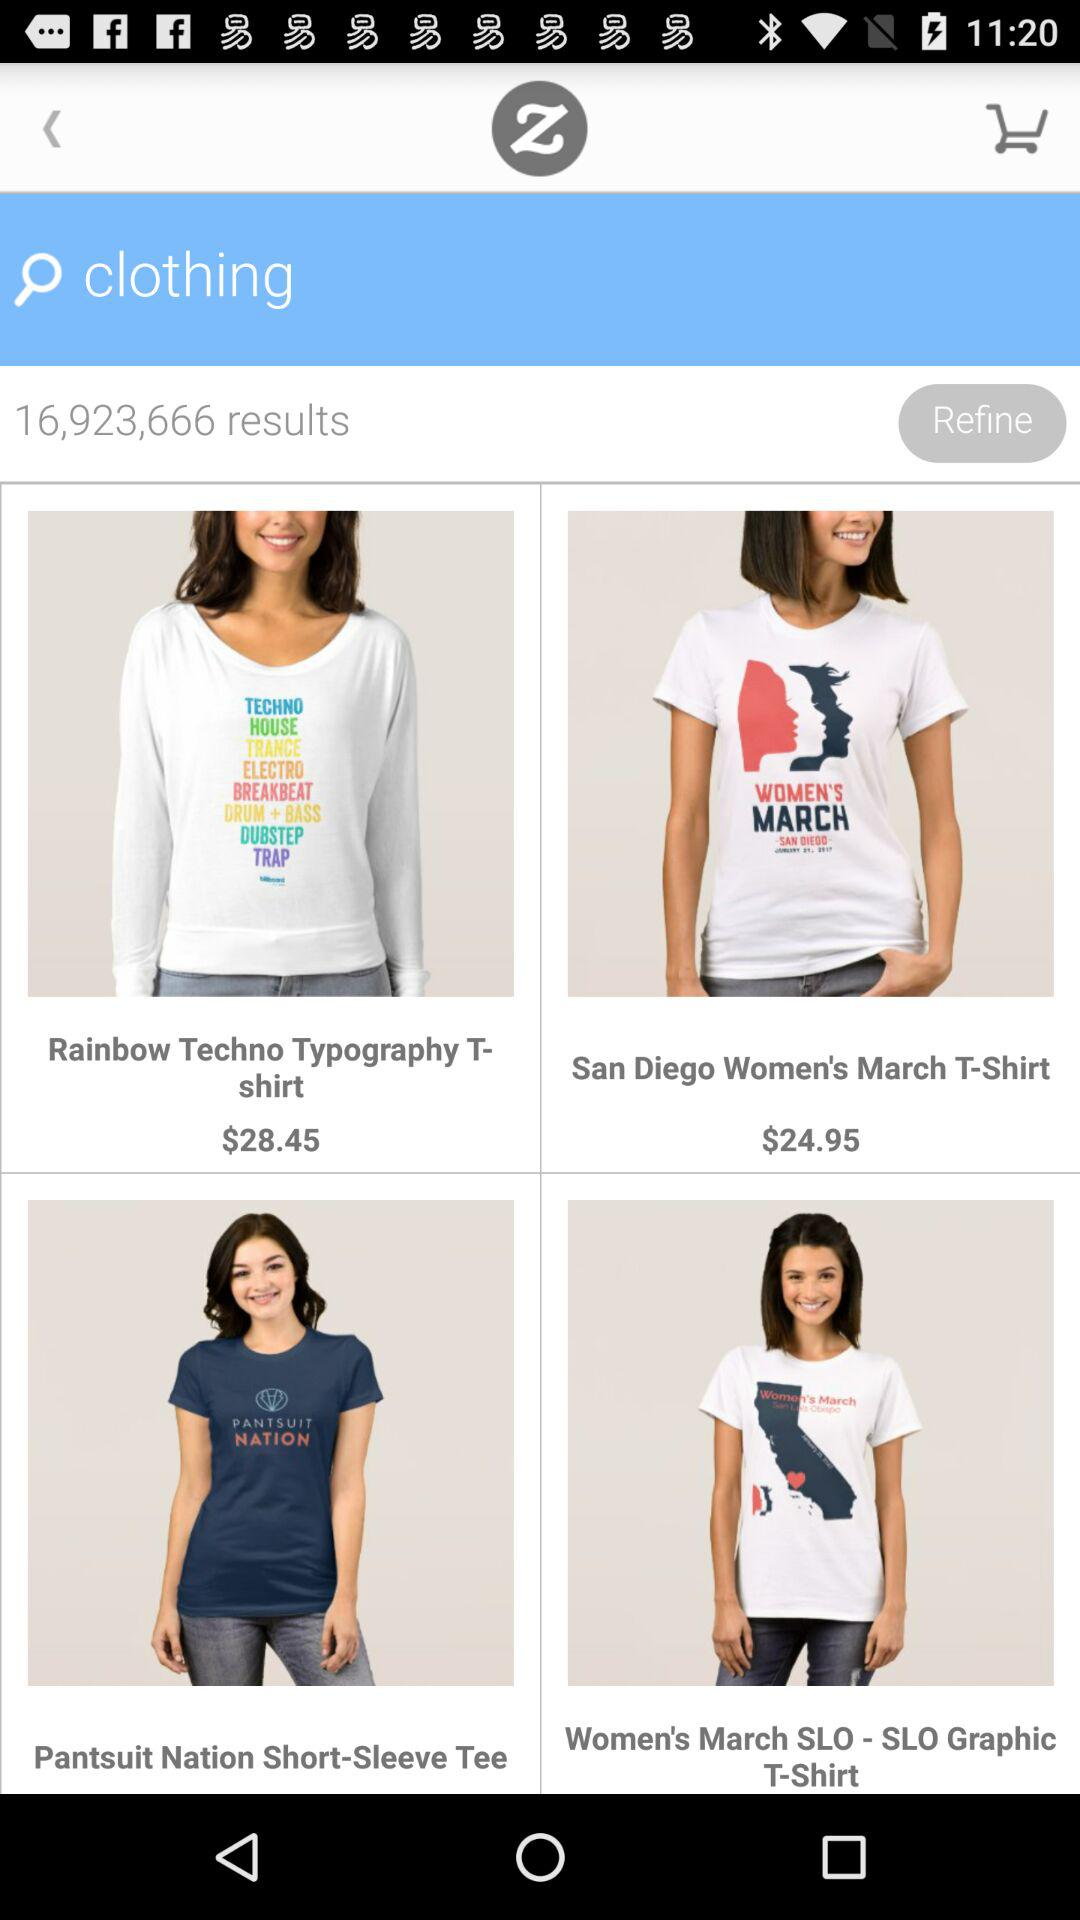What is the price of "San Diego Women's March T-Shirt"? The price of "San Diego Women's March T-Shirt" is $24.95. 